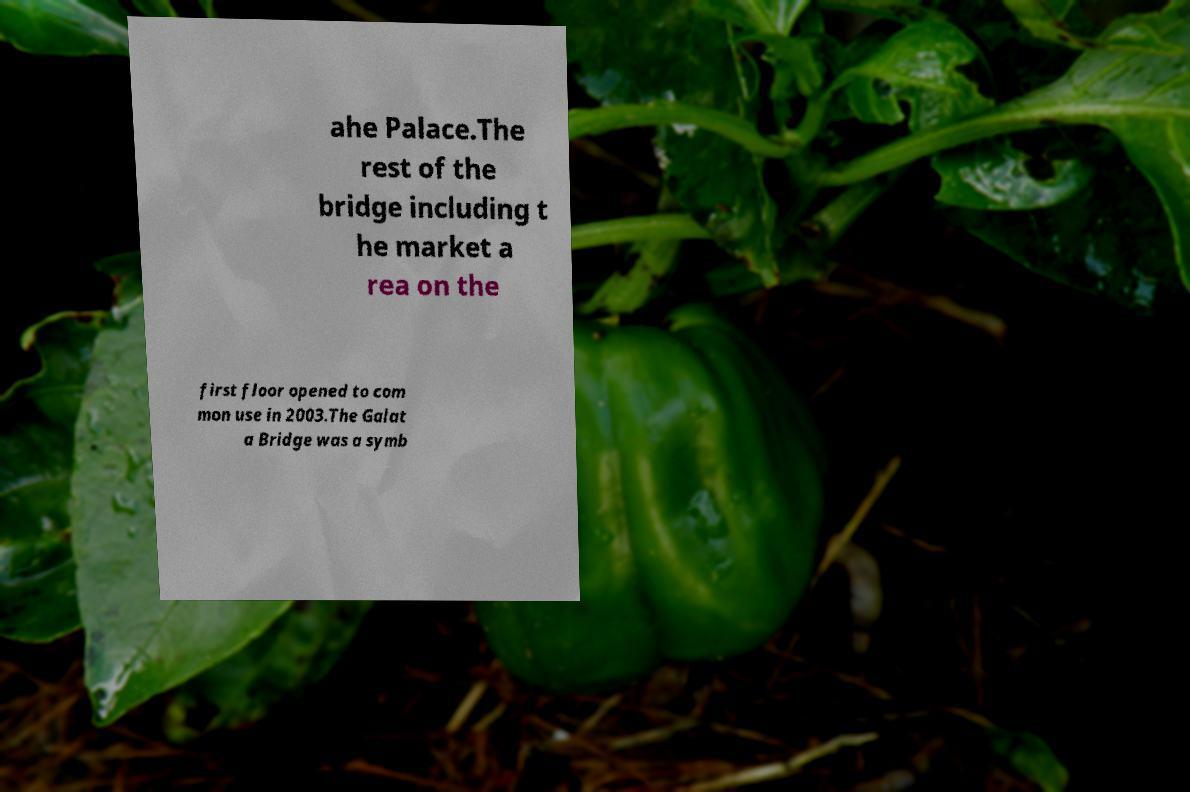For documentation purposes, I need the text within this image transcribed. Could you provide that? ahe Palace.The rest of the bridge including t he market a rea on the first floor opened to com mon use in 2003.The Galat a Bridge was a symb 